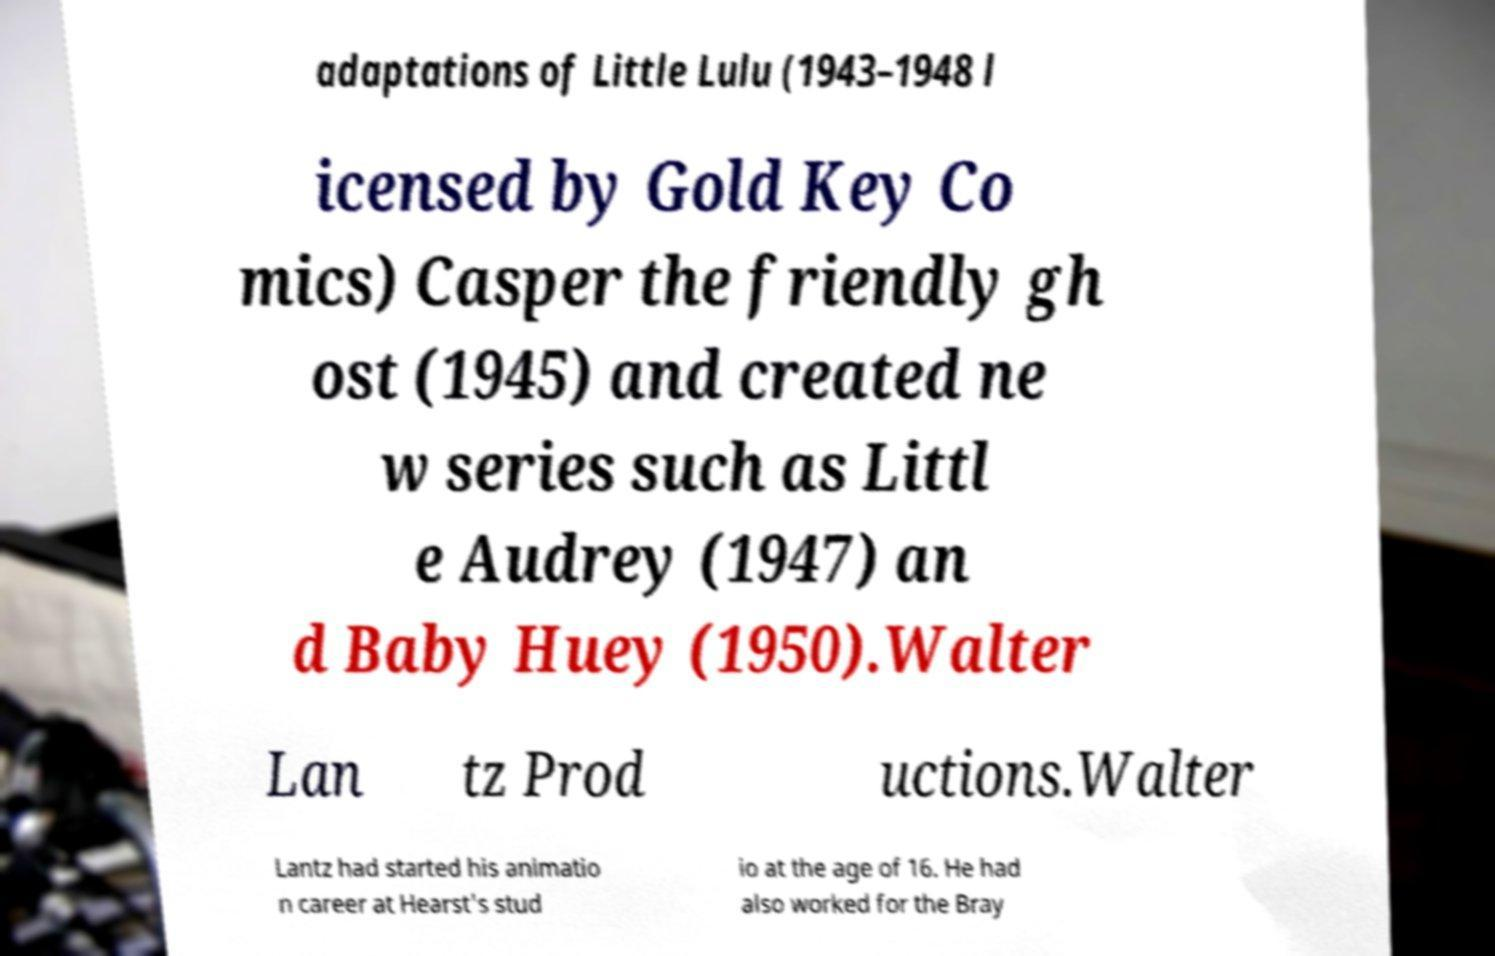Could you assist in decoding the text presented in this image and type it out clearly? adaptations of Little Lulu (1943–1948 l icensed by Gold Key Co mics) Casper the friendly gh ost (1945) and created ne w series such as Littl e Audrey (1947) an d Baby Huey (1950).Walter Lan tz Prod uctions.Walter Lantz had started his animatio n career at Hearst's stud io at the age of 16. He had also worked for the Bray 